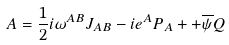Convert formula to latex. <formula><loc_0><loc_0><loc_500><loc_500>A = \frac { 1 } { 2 } i \omega ^ { A B } J _ { A B } - i e ^ { A } P _ { A } + + \overline { \psi } Q</formula> 